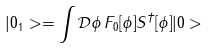Convert formula to latex. <formula><loc_0><loc_0><loc_500><loc_500>| 0 _ { 1 } > = \int \mathcal { D } \phi \, F _ { 0 } [ \phi ] S ^ { \dagger } [ \phi ] | 0 ></formula> 